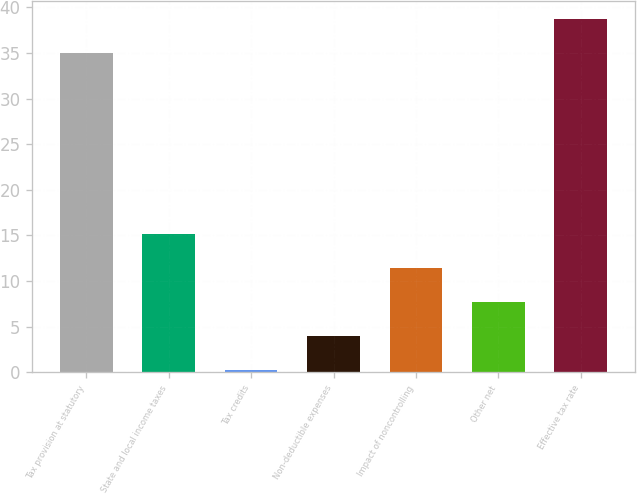Convert chart. <chart><loc_0><loc_0><loc_500><loc_500><bar_chart><fcel>Tax provision at statutory<fcel>State and local income taxes<fcel>Tax credits<fcel>Non-deductible expenses<fcel>Impact of noncontrolling<fcel>Other net<fcel>Effective tax rate<nl><fcel>35<fcel>15.16<fcel>0.2<fcel>3.94<fcel>11.42<fcel>7.68<fcel>38.74<nl></chart> 